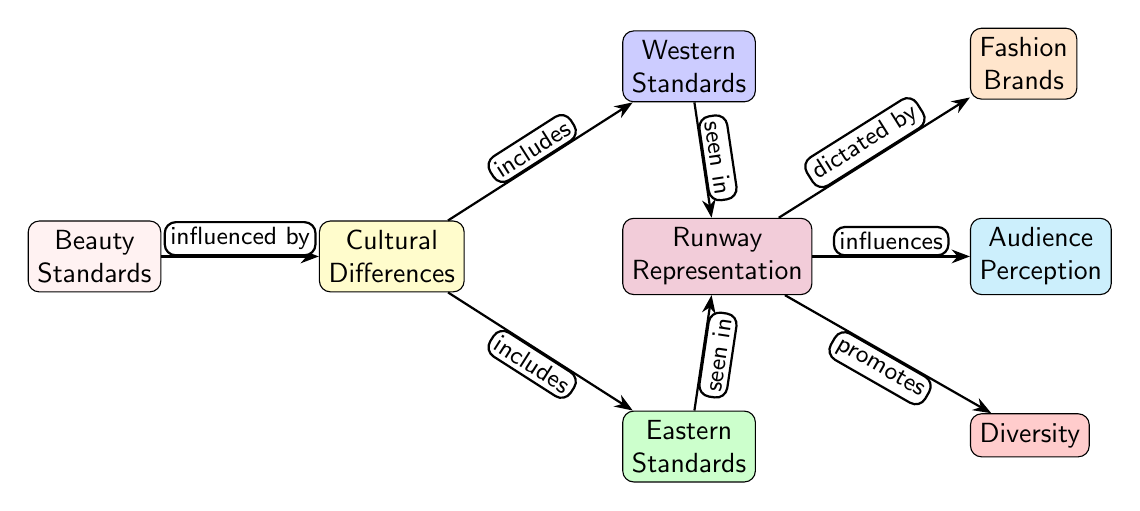What are the two main categories of beauty standards? The diagram shows that beauty standards encompass both Western and Eastern standards, represented as distinct nodes branching from the cultural differences node.
Answer: Western and Eastern How many nodes are connected to the runway representation node? By counting the edges from the runway representation node, we can see there are three nodes associated with it: fashion brands, audience perception, and diversity, indicating its broad influence.
Answer: Three What relationship exists between cultures and beauty standards? The diagram illustrates that beauty standards are influenced by cultural differences, with the arrow labeled "influenced by" indicating this connection clearly.
Answer: Influenced by What does diversity promote in the context of runway representation? The diagram indicates that diversity promotes different representation on runways, connecting the diversity node with a clear edge labeled "promotes."
Answer: Runway representation Which type of standards is included within the cultural differences node? Looking at the nodes connected under cultural differences, it shows that both Western and Eastern standards are included in that category.
Answer: Western and Eastern What node is directly influenced by fashion brands according to the diagram? The diagram specifies that runway representation is dictated by fashion brands, establishing a direct influence between these two nodes, as demonstrated by the arrow labeled "dictated by."
Answer: Runway representation How does the runway representation impact audience perception? The edge labeled "influences" indicates a direct connection where runway representation has a significant effect on how audiences perceive beauty.
Answer: Influences What is primarily represented in the Western standards node? The Western standards node signifies a specific set of beauty standards related to Western cultures, although specific traits are not detailed in the diagram.
Answer: Western cultures How are cultural differences structured in relation to beauty standards? The diagram outlines that cultural differences directly include both Western and Eastern standards, showcasing a hierarchical relationship illustrated through the connecting edges.
Answer: Includes both standards 